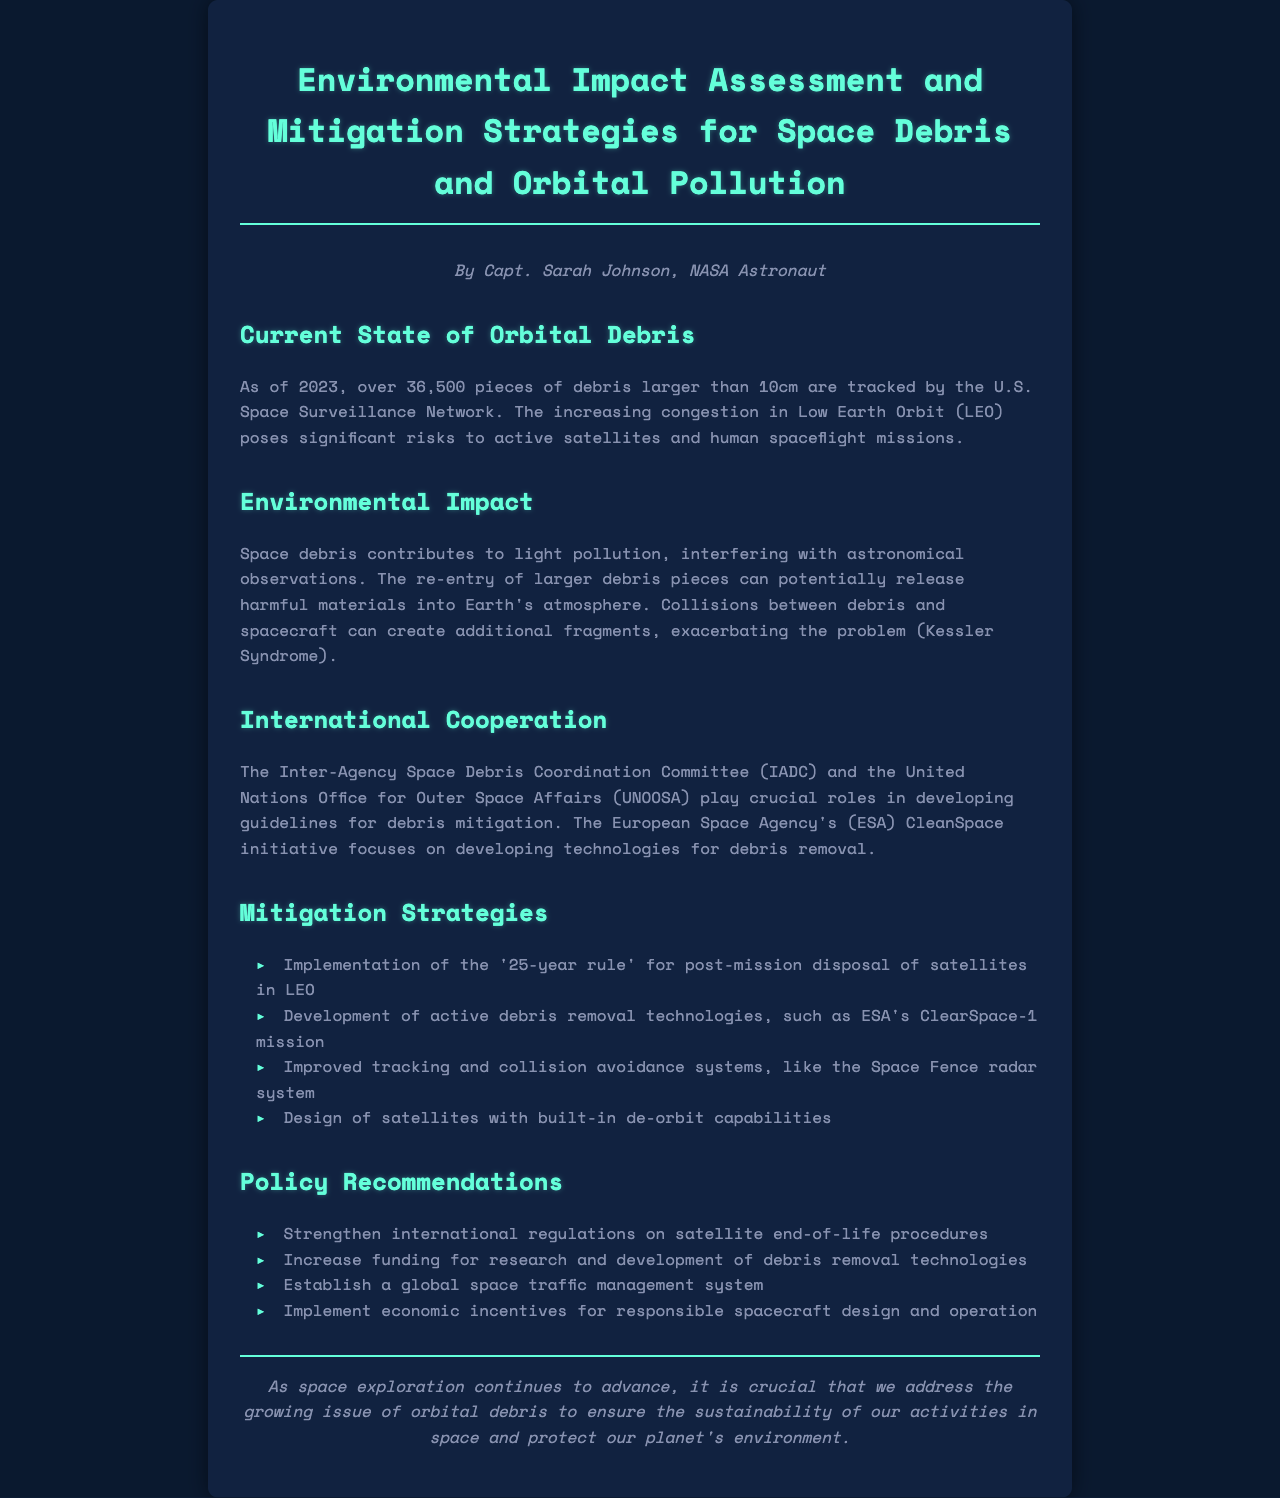What is the current number of tracked debris pieces larger than 10cm? The document states that over 36,500 pieces of debris larger than 10cm are tracked.
Answer: Over 36,500 What potential environmental impact is caused by the re-entry of larger debris pieces? The document mentions that re-entry can potentially release harmful materials into Earth's atmosphere.
Answer: Harmful materials Which organization focuses on guidelines for debris mitigation? The document cites the Inter-Agency Space Debris Coordination Committee (IADC) as a crucial organization for developing guidelines.
Answer: IADC What is the '25-year rule'? The document refers to the '25-year rule' as a guideline for post-mission disposal of satellites in Low Earth Orbit.
Answer: Post-mission disposal What technology is ESA testing for debris removal? The document highlights ESA's ClearSpace-1 mission as an active debris removal technology under development.
Answer: ClearSpace-1 How does space debris contribute to light pollution? The document indicates that space debris interferes with astronomical observations, contributing to light pollution.
Answer: Interfering with astronomical observations What is a recommended policy for satellite end-of-life procedures? The document recommends strengthening international regulations on satellite end-of-life procedures.
Answer: Strengthen regulations What system is suggested for improving tracking and collision avoidance? The document mentions the Space Fence radar system as an improved tracking and collision avoidance system.
Answer: Space Fence What is the focus of the European Space Agency's CleanSpace initiative? According to the document, the CleanSpace initiative focuses on developing technologies for debris removal.
Answer: Debris removal technologies 